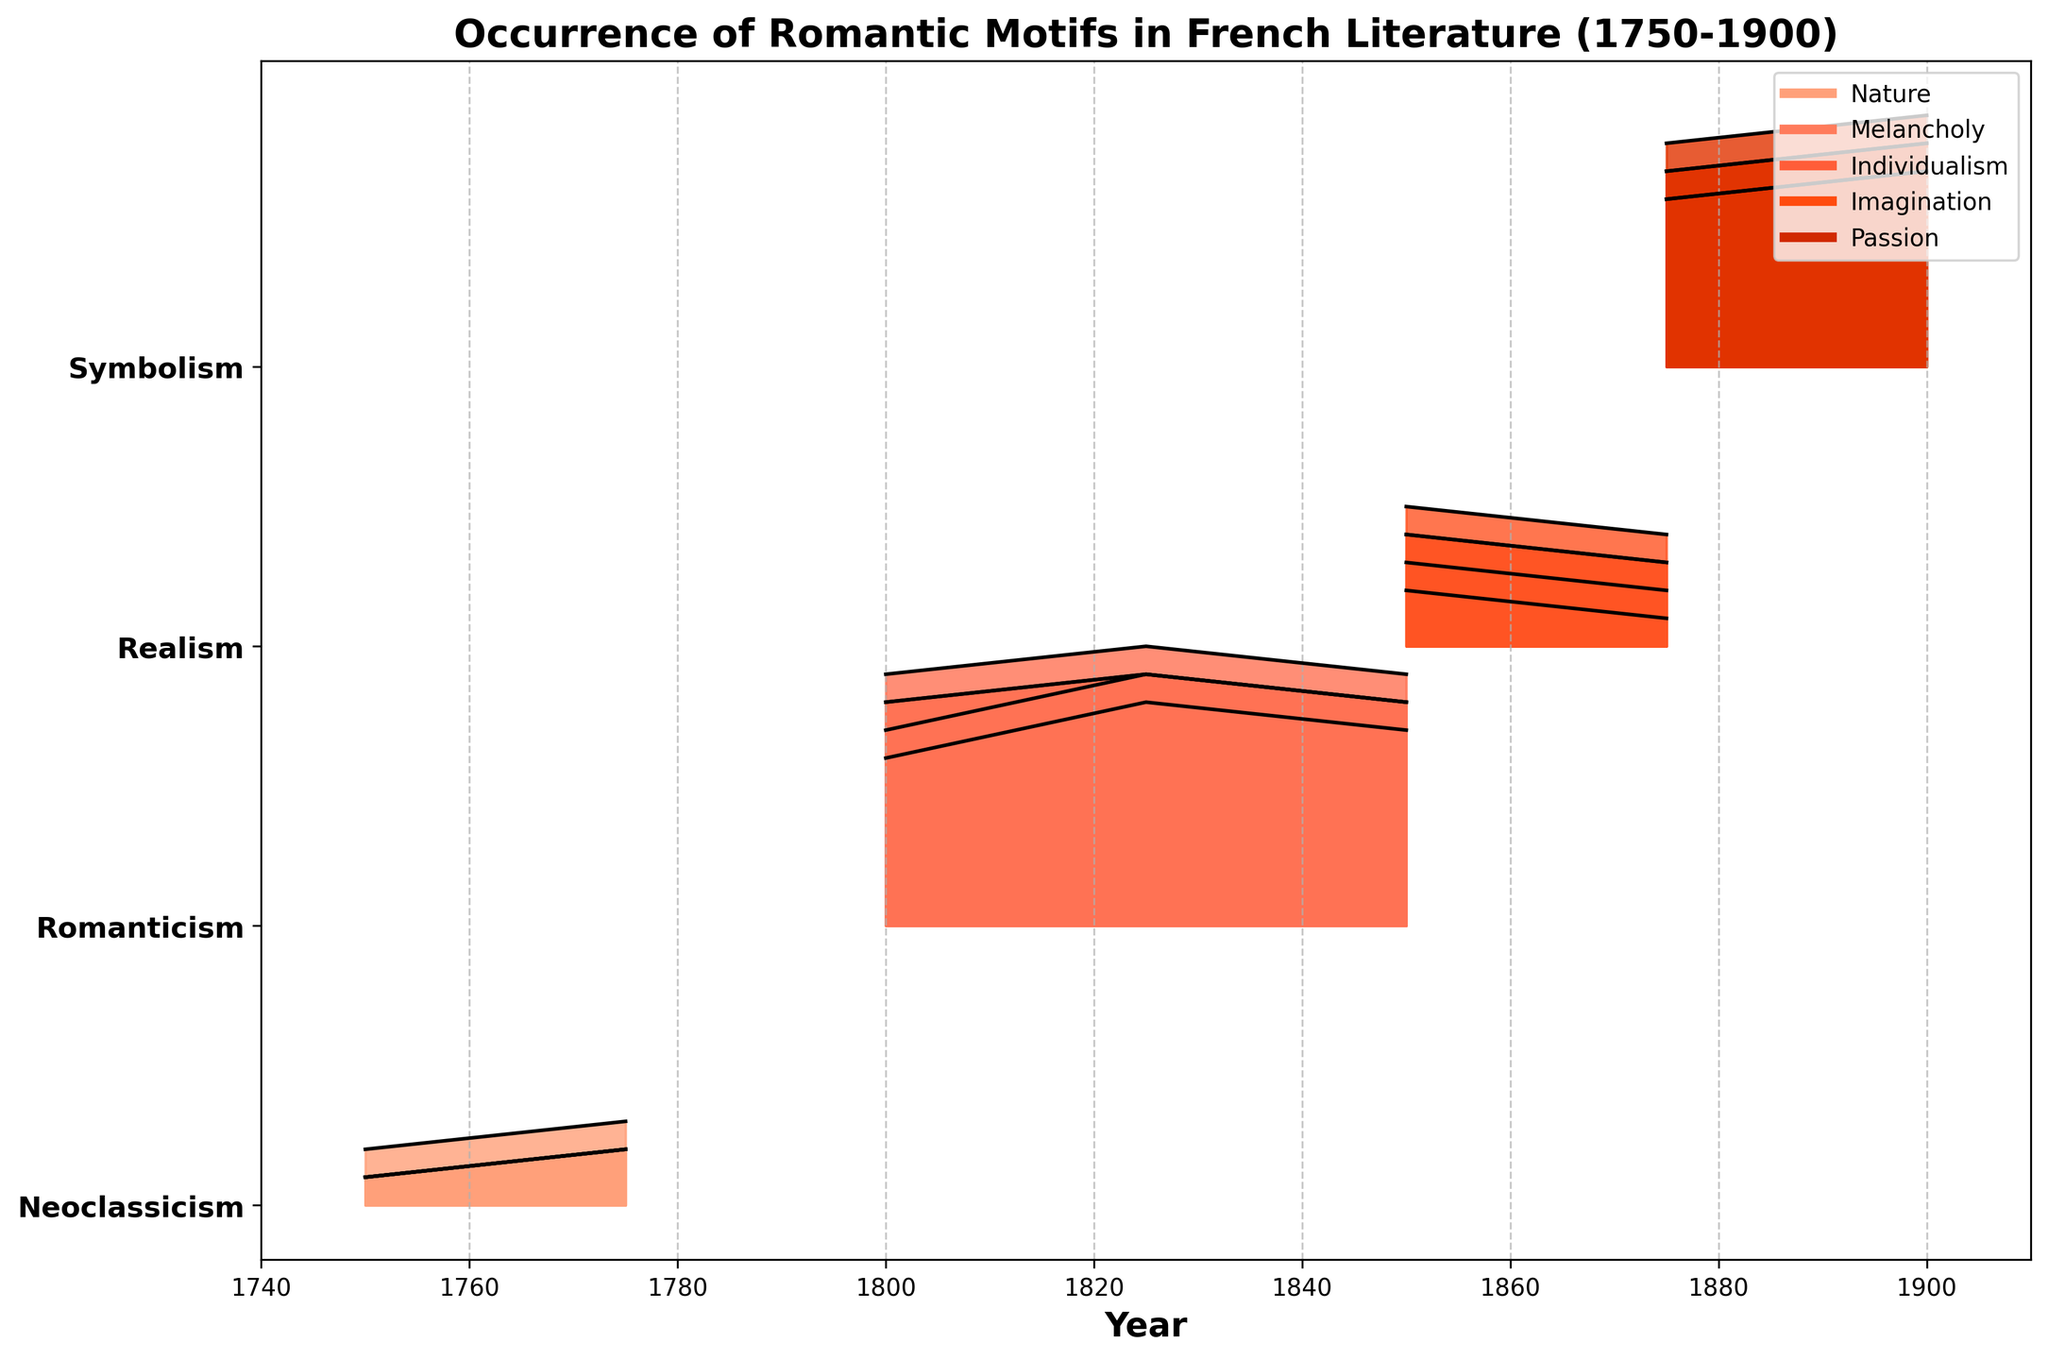What is the title of the figure? The title is usually shown at the top of the figure. By examining the figure, you can read the title directly.
Answer: Occurrence of Romantic Motifs in French Literature (1750-1900) Which movement has the highest occurrence of the motif "Imagination" according to the figure? By looking at the 'Imagination' motif across different movements, identify the peak value. Observe that Romanticism around 1825 has the highest value at 1.0.
Answer: Romanticism During which years does the Neoclassicism movement appear in the figure? Neoclassicism corresponds to the first row (at the bottom) of the figure. By looking horizontally, we can see it appears around 1750 and 1775.
Answer: 1750, 1775 Which two motifs have the closest occurrence values in Symbolism around the year 1900? Symbolism's bands around 1900 show that 'Nature' and 'Individualism' have occurrences of 0.7 respectively, making them almost identical. 'Melancholy' and 'Passion' also both have values of 0.8. Thus, we have two possible pairs here.
Answer: Nature and Individualism, Melancholy and Passion How does the occurrence of "Melancholy" change from Neoclassicism to Romanticism? Compare the 'Melancholy' values in Neoclassicism (0.1 to 0.2) with those in Romanticism (0.6 to 0.8). Notice a significant increase.
Answer: It increases significantly Across all movements, which motif has the least variation in occurrence? Check the amplitude of oscillation of each motif's representation over each movement. 'Passion' shows the least variation since its values stay within 0.1 to 0.9 without large jumps.
Answer: Passion What happens to the occurrence of Romantic motifs in Realism between 1850 and 1875? Examine the Realism row from 1850 to 1875 and notice that all motifs decrease in occurrence, for instance, 'Nature' decreases from 0.5 to 0.4.
Answer: They decrease Which years show the highest occurrence of all five motifs combined? Find the point where all motifs' values visually appear to peak. For instance, around 1825 in Romanticism, where most values are near or at the top (close to 1).
Answer: Around 1825 What visual element indicates the leaders of different subplots (movements) in the Ridgeline plot? The legend on the upper right-hand side along with black lines representing the boundaries of filled areas in each plot.
Answer: Black lines and legend 